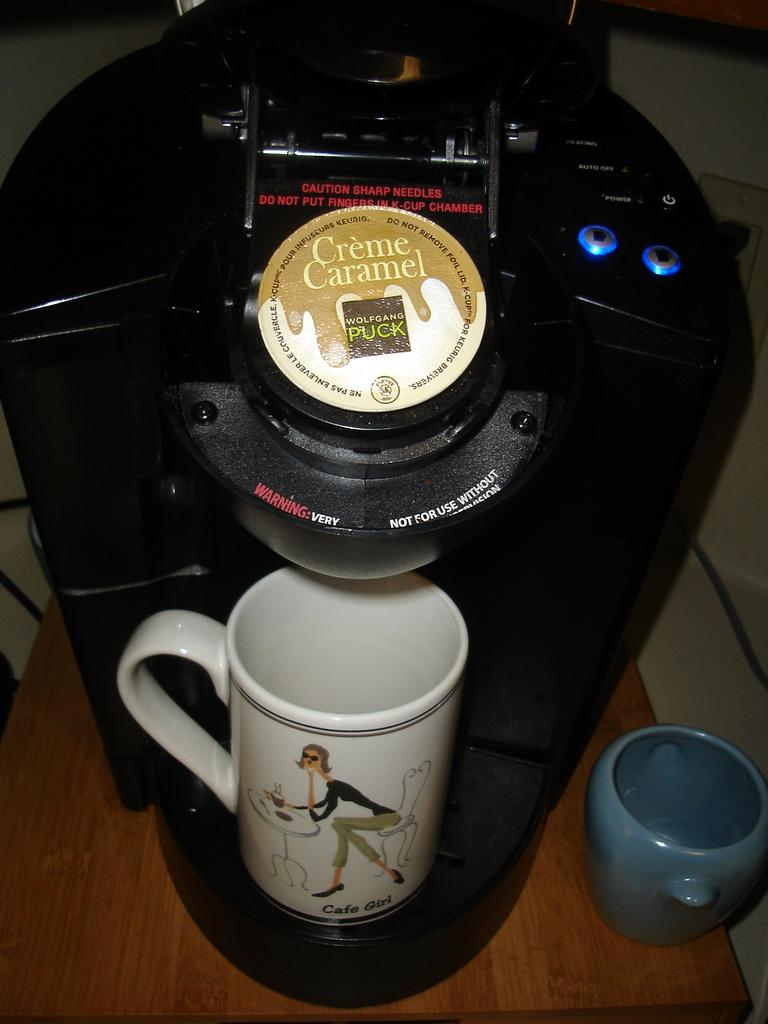<image>
Summarize the visual content of the image. A coffee machine with a single serve coffee container that is Creme Caramel flavored. 